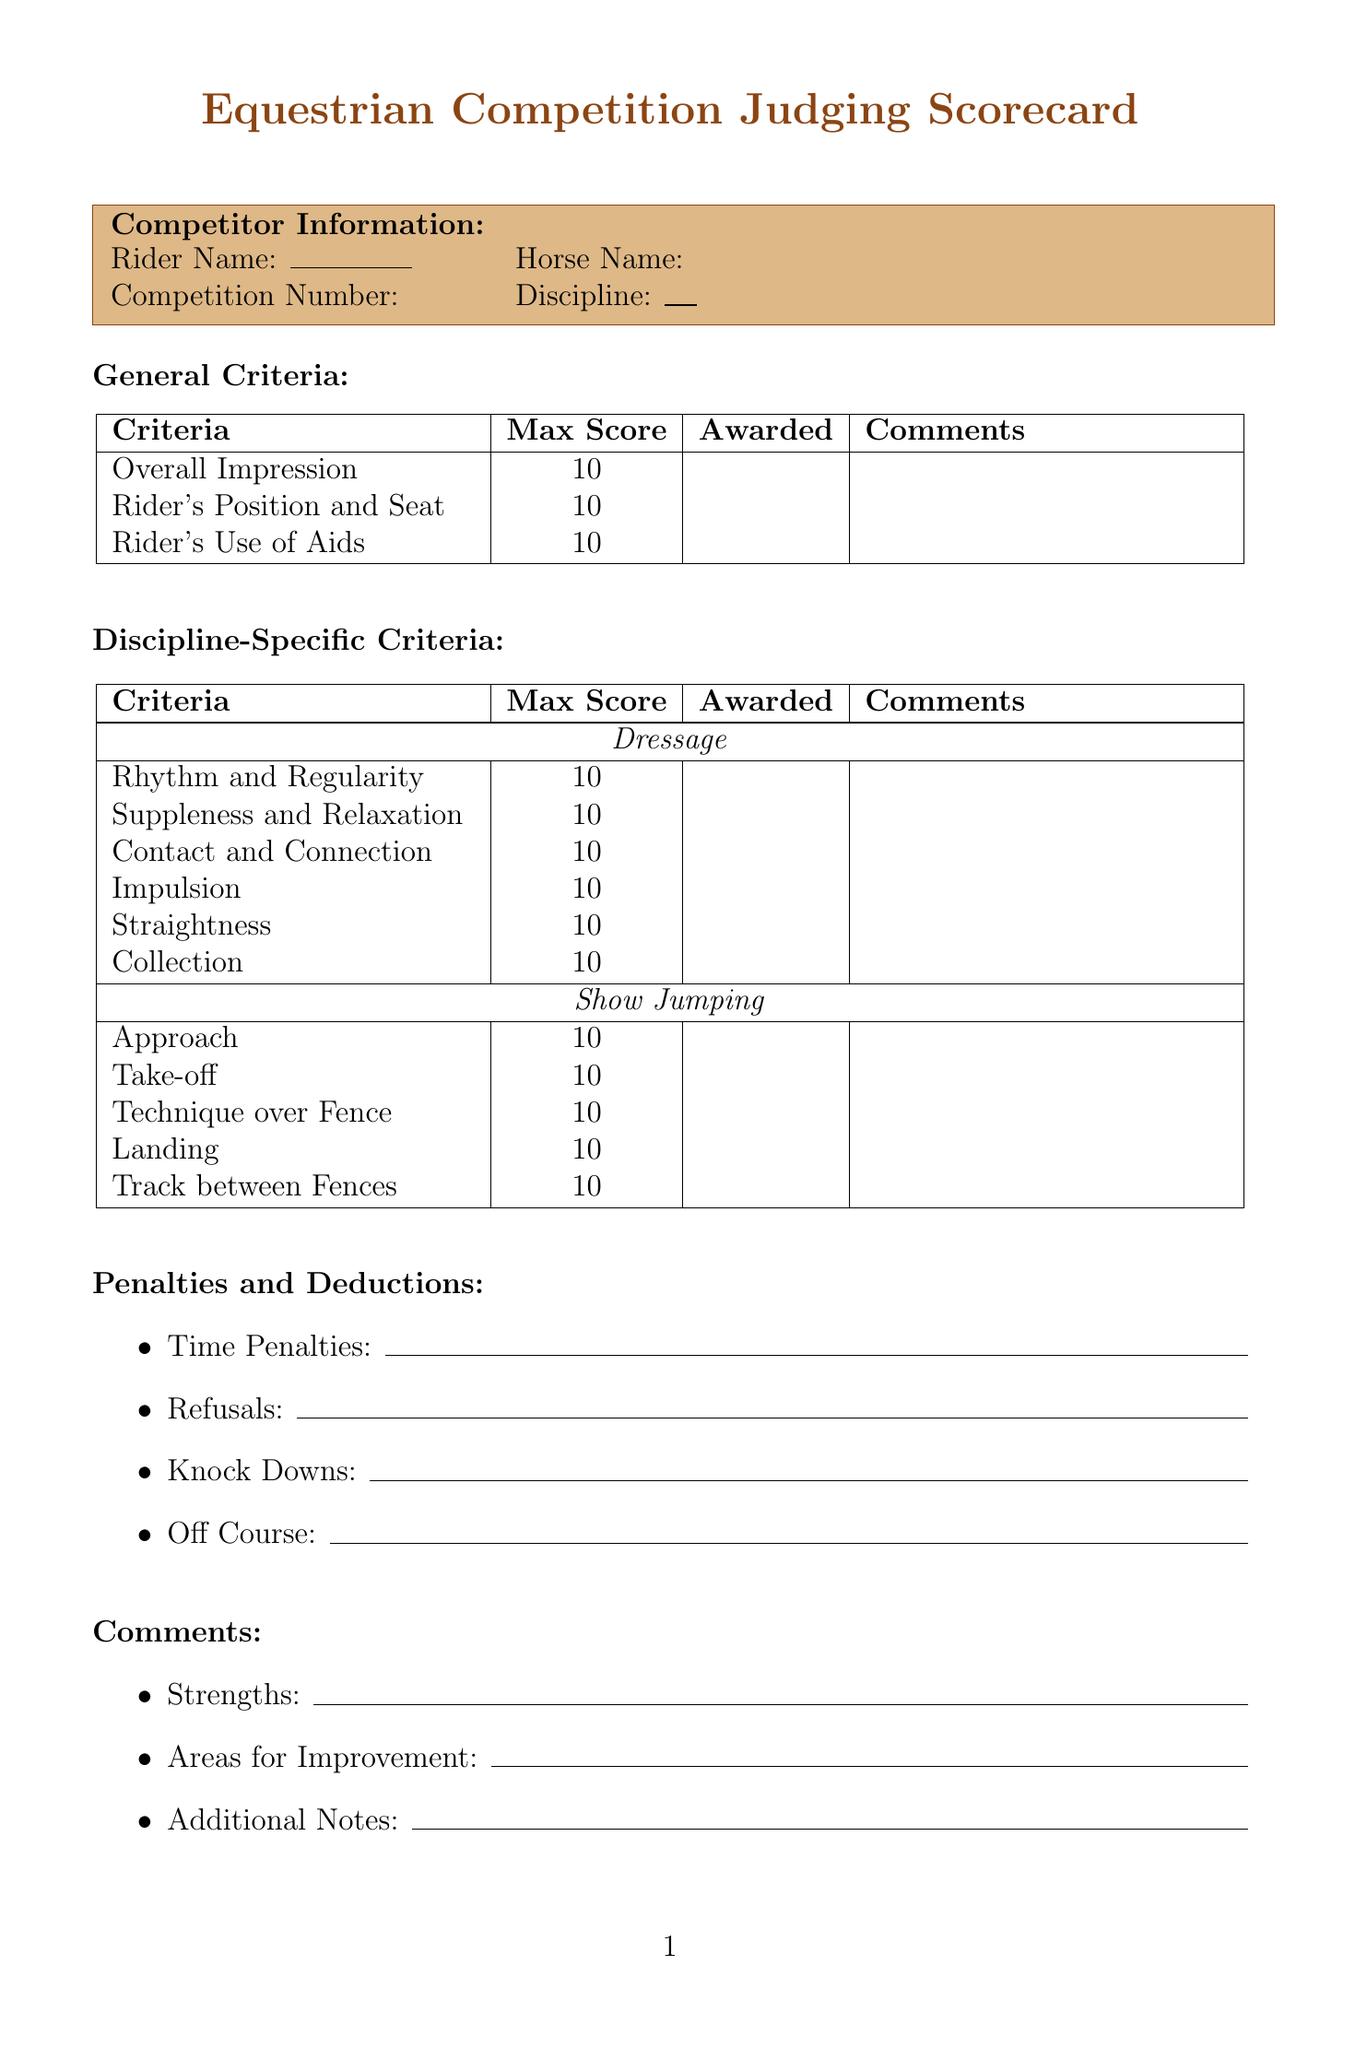What is the title of the document? The title of the document is presented at the top of the scorecard and states its purpose.
Answer: Equestrian Competition Judging Scorecard What are the names of the disciplines listed? The disciplines are specifically enumerated in a list format in the document.
Answer: Dressage, Show Jumping, Eventing, Western Pleasure, Reining How many general criteria are there? The number of general criteria can be counted from the section where they are listed.
Answer: 3 What is the maximum score for "Contact and Connection"? The maximum score is mentioned alongside each specific criterion in the discipline-specific sections.
Answer: 10 What are the penalties mentioned in the document? The document lists specific types of penalties in a bullet point format.
Answer: Time Penalties, Refusals, Knock Downs, Off Course Which section includes space for judge information? The section where judge information is provided is clearly titled in the document.
Answer: Judge Information What is the criterion for "Manners"? The criterion name is specified in the Western Pleasure discipline's criteria section of the document.
Answer: Manners What is required for the final score calculation? The final score section summarizes how to compute the final score based on the given criteria and deductions.
Answer: Total Score minus Deductions 